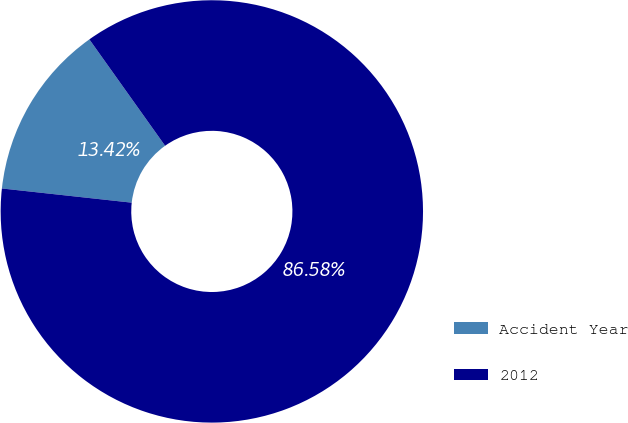Convert chart to OTSL. <chart><loc_0><loc_0><loc_500><loc_500><pie_chart><fcel>Accident Year<fcel>2012<nl><fcel>13.42%<fcel>86.58%<nl></chart> 